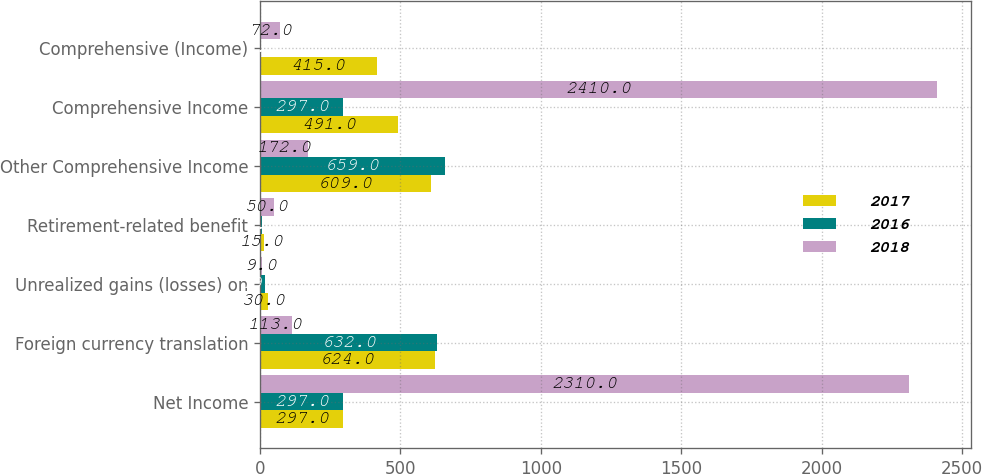Convert chart to OTSL. <chart><loc_0><loc_0><loc_500><loc_500><stacked_bar_chart><ecel><fcel>Net Income<fcel>Foreign currency translation<fcel>Unrealized gains (losses) on<fcel>Retirement-related benefit<fcel>Other Comprehensive Income<fcel>Comprehensive Income<fcel>Comprehensive (Income)<nl><fcel>2017<fcel>297<fcel>624<fcel>30<fcel>15<fcel>609<fcel>491<fcel>415<nl><fcel>2016<fcel>297<fcel>632<fcel>19<fcel>8<fcel>659<fcel>297<fcel>4<nl><fcel>2018<fcel>2310<fcel>113<fcel>9<fcel>50<fcel>172<fcel>2410<fcel>72<nl></chart> 